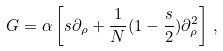Convert formula to latex. <formula><loc_0><loc_0><loc_500><loc_500>G = \alpha \left [ s \partial _ { \rho } + \frac { 1 } { N } ( 1 - \frac { s } { 2 } ) \partial _ { \rho } ^ { 2 } \right ] \, ,</formula> 